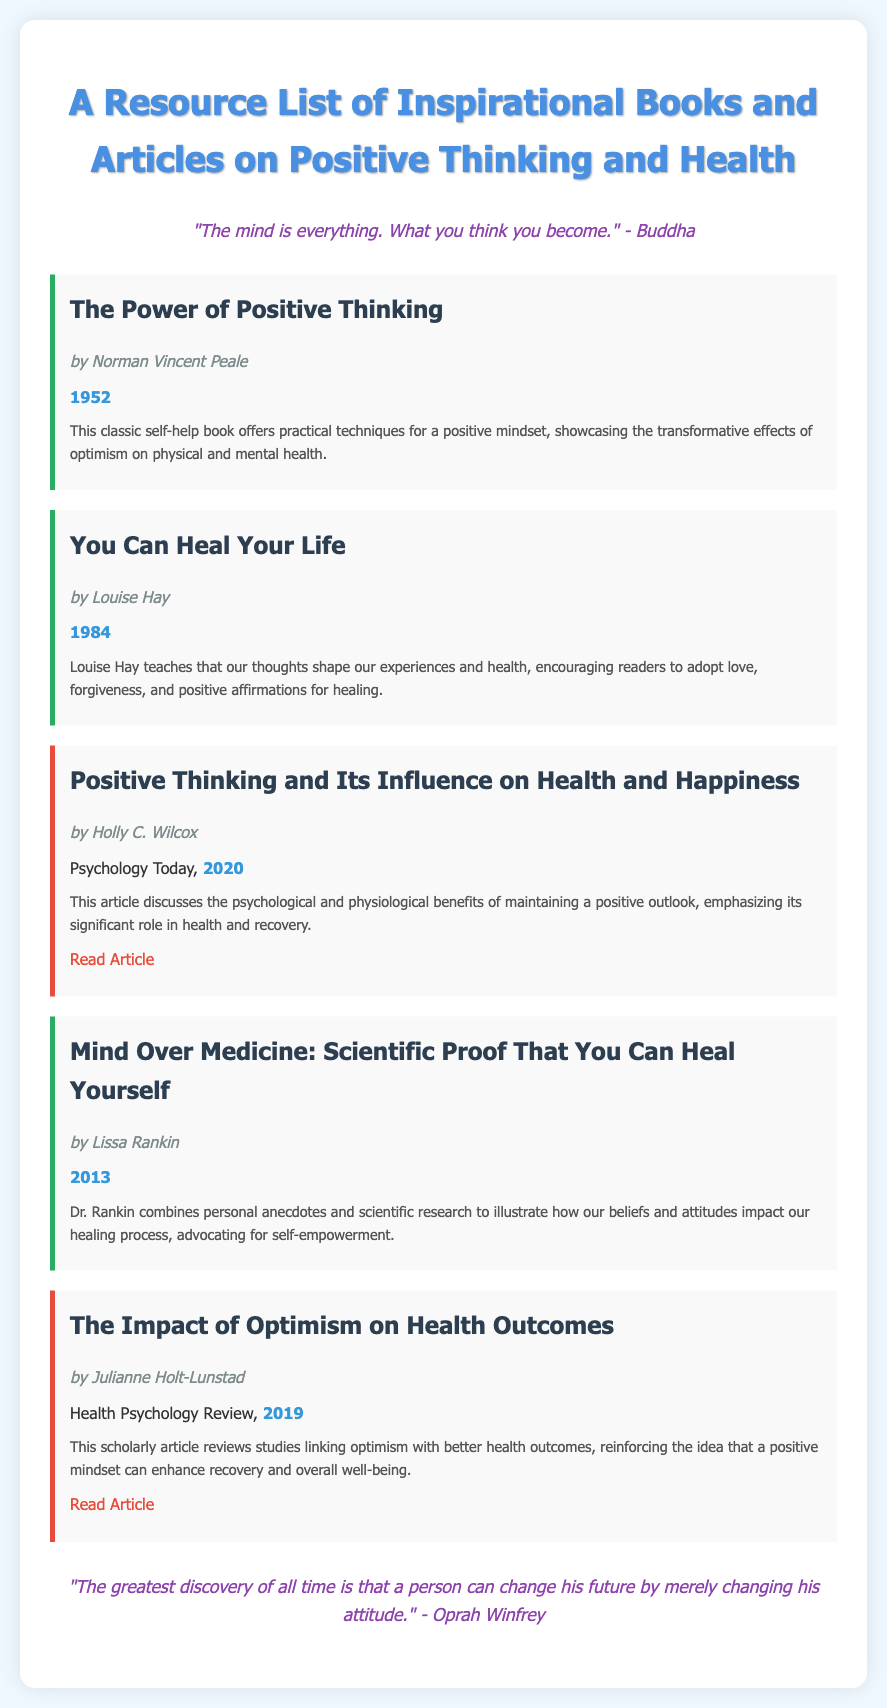What is the title of the first book listed? The title of the first book listed in the document is mentioned as part of the resource section.
Answer: The Power of Positive Thinking Who is the author of "You Can Heal Your Life"? The author's name for this specific book is provided directly in the document.
Answer: Louise Hay What year was "Mind Over Medicine" published? The publication year is included in the description of the book section.
Answer: 2013 Which article emphasizes the psychological benefits of positive thinking? This requires understanding the summaries of the articles, identifying one that highlights psychological benefits.
Answer: Positive Thinking and Its Influence on Health and Happiness What color is used for resource titles in the document? The title of each resource is highlighted with specific color coding mentioned in the document's style section.
Answer: #2c3e50 What significant theme is repeated in the quotes provided? By examining both quotes, a common theme related to mindset and attitude can be inferred.
Answer: Positive thinking 